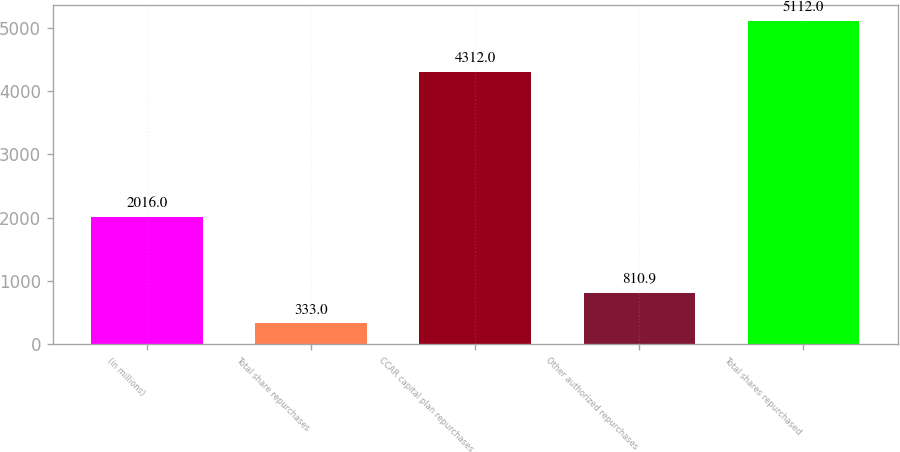Convert chart to OTSL. <chart><loc_0><loc_0><loc_500><loc_500><bar_chart><fcel>(in millions)<fcel>Total share repurchases<fcel>CCAR capital plan repurchases<fcel>Other authorized repurchases<fcel>Total shares repurchased<nl><fcel>2016<fcel>333<fcel>4312<fcel>810.9<fcel>5112<nl></chart> 